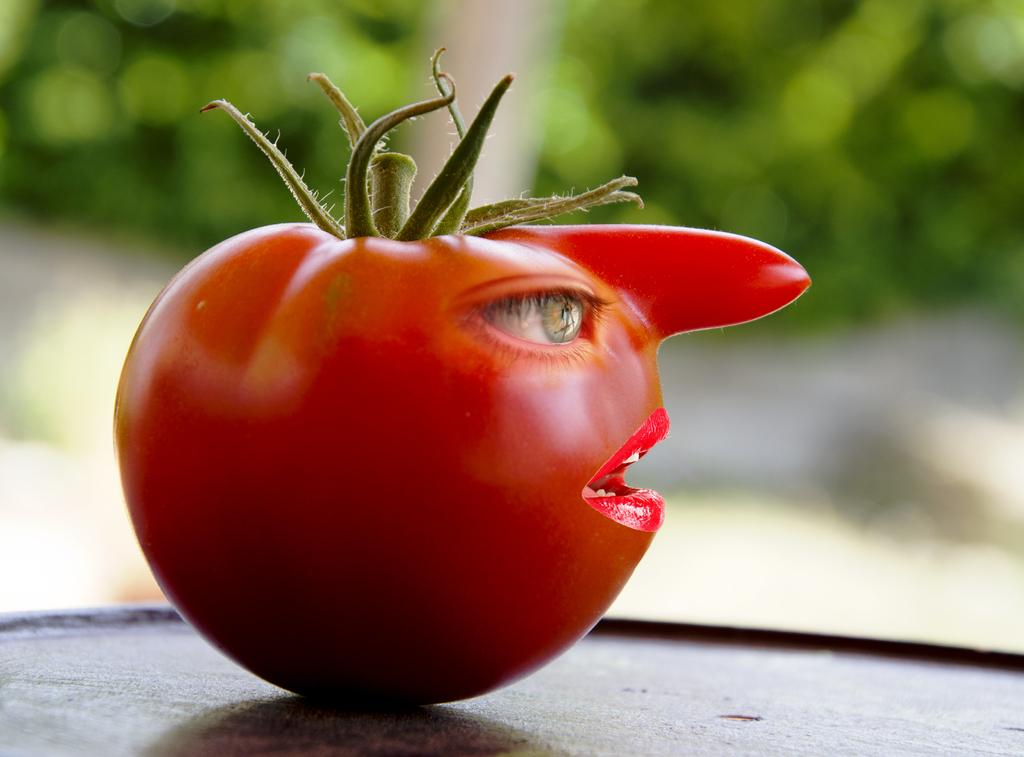What is the main subject of the image? The main subject of the image is a tomato. What facial features are drawn on the tomato? The tomato has an eye, a nose, and lips drawn on it. What is the temperature outside, as indicated by the tomato's sweater in the image? There is no sweater present on the tomato in the image, and therefore no indication of temperature. 